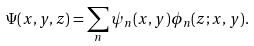Convert formula to latex. <formula><loc_0><loc_0><loc_500><loc_500>\Psi ( x , y , z ) = \sum _ { n } \psi _ { n } ( x , y ) \phi _ { n } ( z ; x , y ) .</formula> 